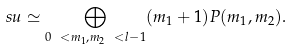Convert formula to latex. <formula><loc_0><loc_0><loc_500><loc_500>\ s u \simeq \bigoplus _ { 0 \ < m _ { 1 } , m _ { 2 } \ < l - 1 } ( m _ { 1 } + 1 ) P ( m _ { 1 } , m _ { 2 } ) .</formula> 